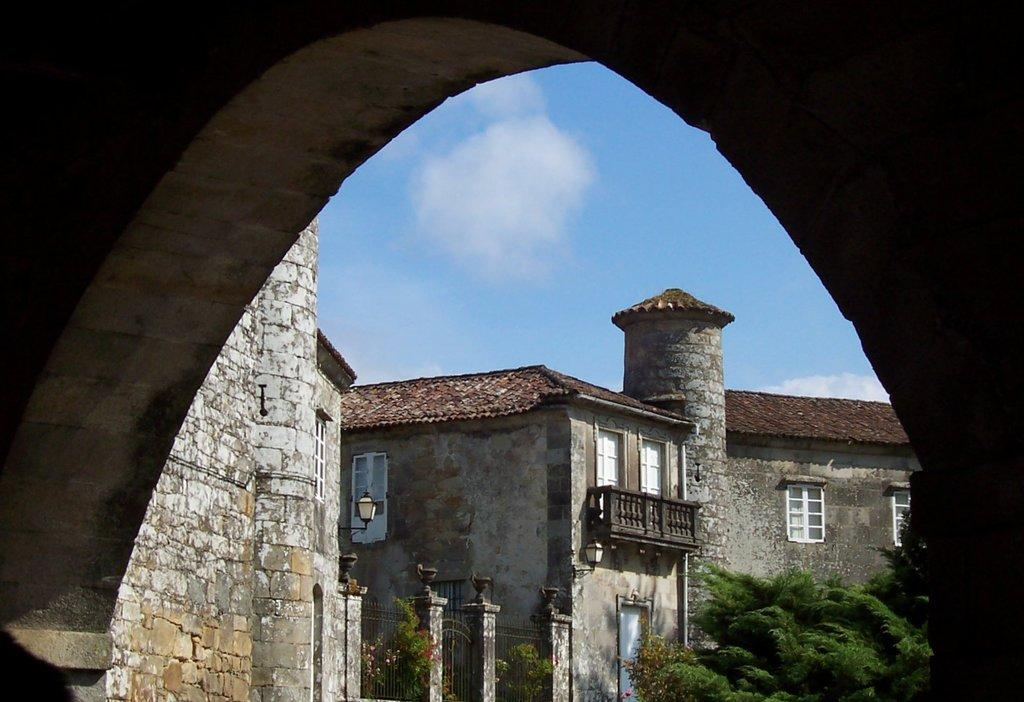What type of structures are present in the image? There are buildings in the image. What are some features of the buildings? The buildings have walls, windows, railings, pillars, and doors. What can be seen at the bottom of the image? There are trees at the bottom of the image. What is visible in the background of the image? The sky is visible in the background of the image. How many sisters are playing together in the image? There are no sisters present in the image; it features buildings, trees, and the sky. What type of attraction can be seen in the image? There is no attraction present in the image; it features buildings, trees, and the sky. 